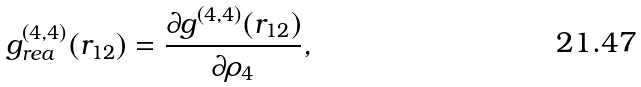<formula> <loc_0><loc_0><loc_500><loc_500>g _ { r e a } ^ { ( 4 , 4 ) } ( r _ { 1 2 } ) = \frac { \partial g ^ { ( 4 , 4 ) } ( r _ { 1 2 } ) } { \partial \rho _ { 4 } } ,</formula> 